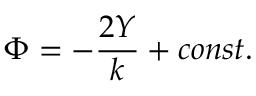Convert formula to latex. <formula><loc_0><loc_0><loc_500><loc_500>\Phi = - \frac { 2 Y } { k } + c o n s t .</formula> 